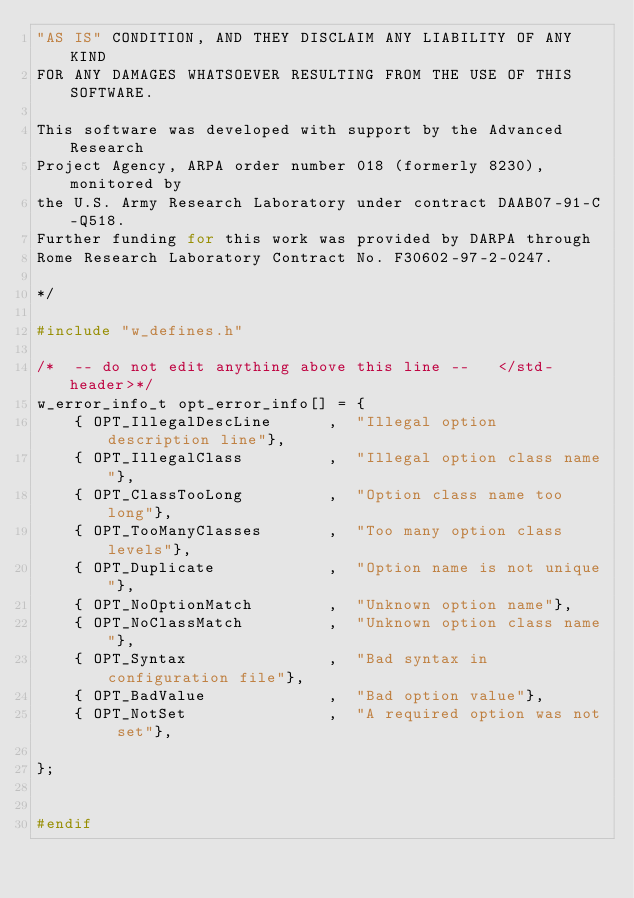Convert code to text. <code><loc_0><loc_0><loc_500><loc_500><_C_>"AS IS" CONDITION, AND THEY DISCLAIM ANY LIABILITY OF ANY KIND
FOR ANY DAMAGES WHATSOEVER RESULTING FROM THE USE OF THIS SOFTWARE.

This software was developed with support by the Advanced Research
Project Agency, ARPA order number 018 (formerly 8230), monitored by
the U.S. Army Research Laboratory under contract DAAB07-91-C-Q518.
Further funding for this work was provided by DARPA through
Rome Research Laboratory Contract No. F30602-97-2-0247.

*/

#include "w_defines.h"

/*  -- do not edit anything above this line --   </std-header>*/
w_error_info_t opt_error_info[] = {
    { OPT_IllegalDescLine      ,  "Illegal option description line"},
    { OPT_IllegalClass         ,  "Illegal option class name"},
    { OPT_ClassTooLong         ,  "Option class name too long"},
    { OPT_TooManyClasses       ,  "Too many option class levels"},
    { OPT_Duplicate            ,  "Option name is not unique"},
    { OPT_NoOptionMatch        ,  "Unknown option name"},
    { OPT_NoClassMatch         ,  "Unknown option class name"},
    { OPT_Syntax               ,  "Bad syntax in configuration file"},
    { OPT_BadValue             ,  "Bad option value"},
    { OPT_NotSet               ,  "A required option was not set"},

};


#endif
</code> 